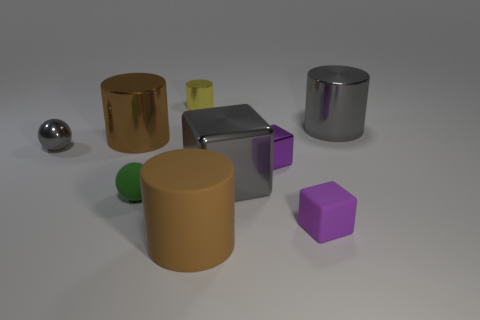Which object stands out the most due to its size? The silver cylinder is the largest object and thus stands out due to its size compared to the others. 